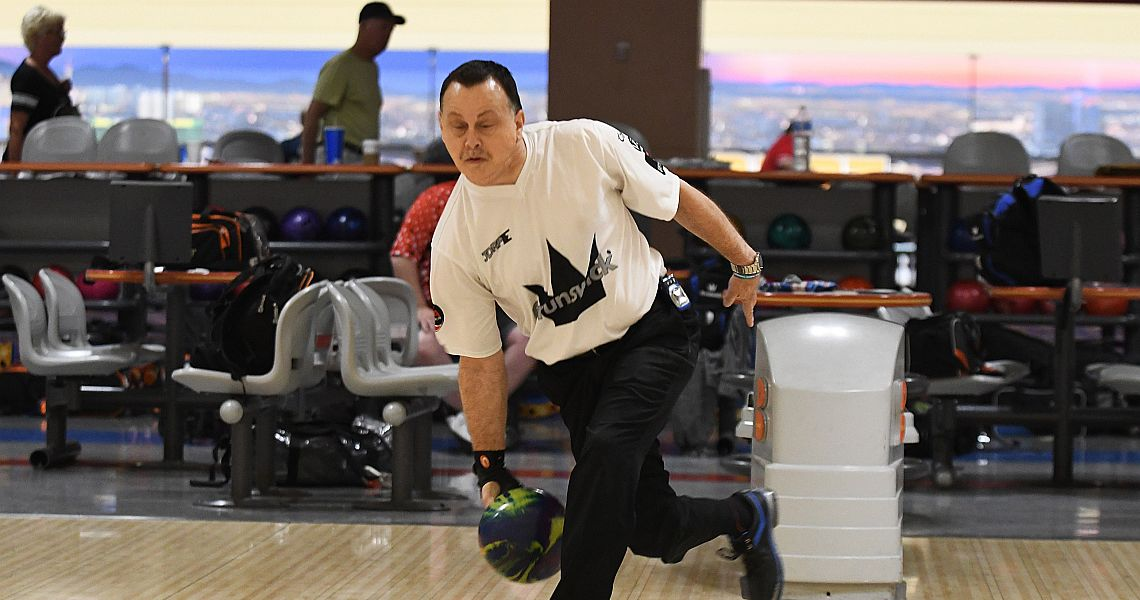Considering the details in the image, create a story where this bowling event is actually a cover for a secret meeting of international spies. The bowling alley buzzed with the sound of pins crashing and casual chatter, a perfect cover for the secret meeting of international spies. In the foreground, Agent Blake, in his league uniform, approached the lane with calculated ease. But his focus wasn't solely on the game; encoded in his wristband was a list of locations for their next covert operation. The others, blending seamlessly with the recreational bowlers, were exchanging coded messages through their personalized equipment. The woman in the red shirt behind him, known as Agent Scarlet, was the communication expert, using the alley's sound system to intercept and decode transmissions. In the background, a seemingly relaxed gentlemen were actually the surveillance experts, their league banter a veil for the micro-drones they controlled, which scanned the perimeter for threats. Their mission was clear: gather intelligence under the guise of a friendly competition, ensuring that their rivals never suspected a thing. As Blake released his ball, he sent a subtle signal to his team – the meeting was live, and they had to play to win, both on the lanes and in their clandestine game of espionage. 